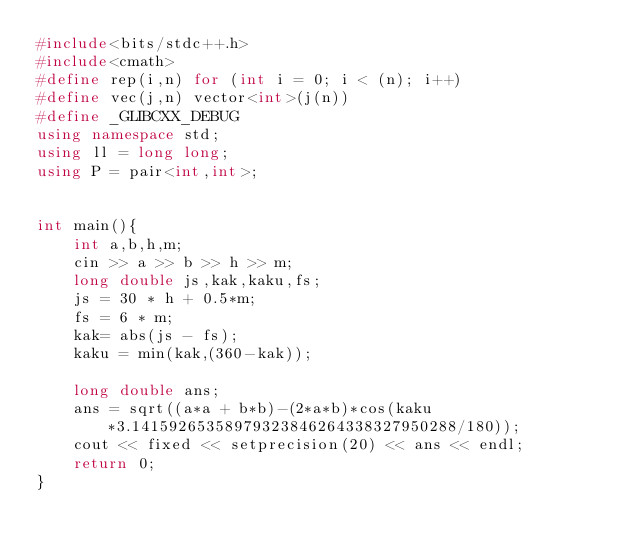<code> <loc_0><loc_0><loc_500><loc_500><_C++_>#include<bits/stdc++.h>
#include<cmath>
#define rep(i,n) for (int i = 0; i < (n); i++)
#define vec(j,n) vector<int>(j(n))
#define _GLIBCXX_DEBUG
using namespace std;
using ll = long long;
using P = pair<int,int>;


int main(){
    int a,b,h,m;
  	cin >> a >> b >> h >> m;
  	long double js,kak,kaku,fs;
    js = 30 * h + 0.5*m;
    fs = 6 * m;
    kak= abs(js - fs);
  	kaku = min(kak,(360-kak));
  	
    long double ans;
    ans = sqrt((a*a + b*b)-(2*a*b)*cos(kaku*3.14159265358979323846264338327950288/180));
    cout << fixed << setprecision(20) << ans << endl;
    return 0;
}</code> 